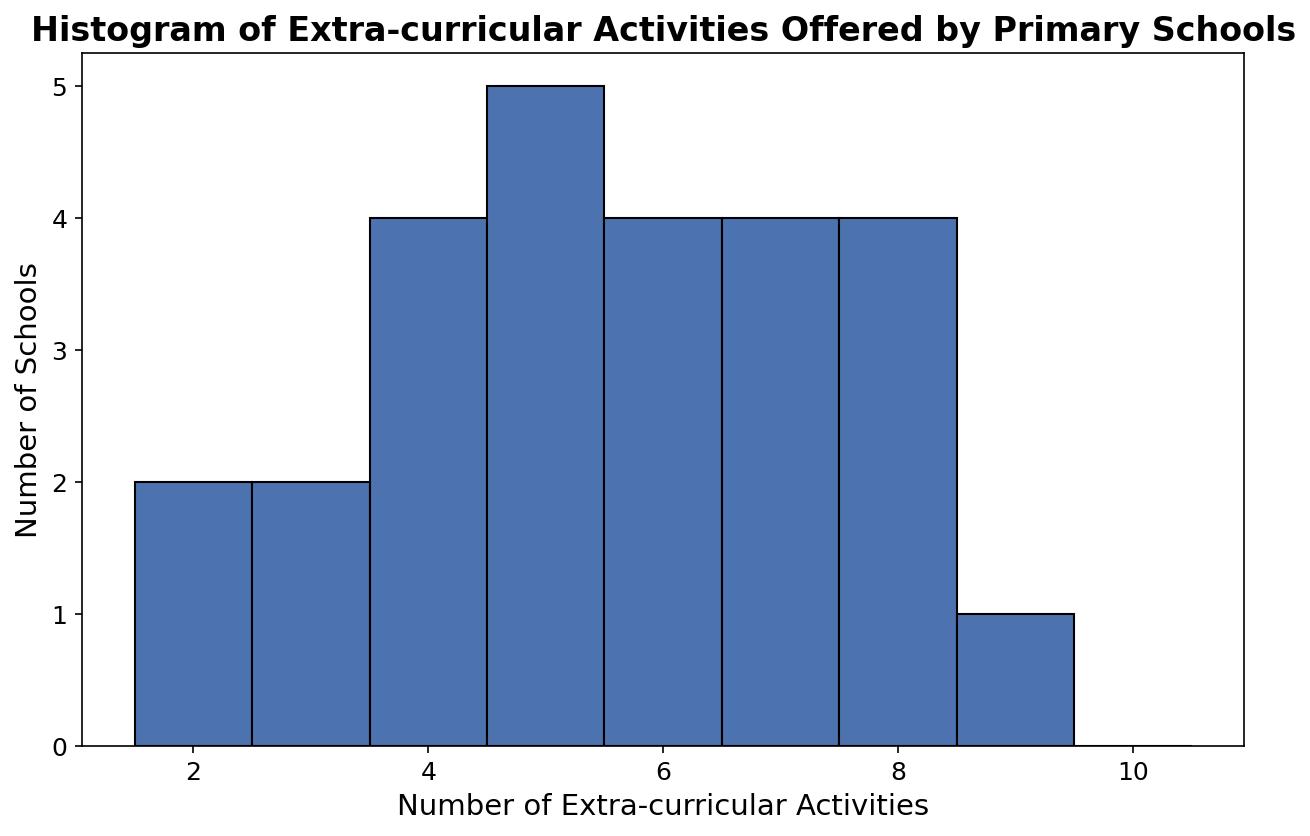How many schools offer exactly 5 extra-curricular activities? To determine this, locate the bar that corresponds to 5 extra-curricular activities. Count the height of this bar, which represents the number of schools.
Answer: 4 Which number of extra-curricular activities is most common among the schools? Identify the tallest bar in the histogram. The label on the x-axis at the base of this bar represents the most common number of extra-curricular activities.
Answer: 7 How many more schools offer 7 activities compared to those that offer 3 activities? First, find the height of the bars corresponding to 7 and 3 activities. Subtract the number of schools that offer 3 activities from those that offer 7.
Answer: 2 What is the total number of schools that offer more than 6 extra-curricular activities? Locate the bars corresponding to 7, 8, and 9 activities. Sum their heights to find the total number of schools offering more than 6 activities.
Answer: 10 Are there more schools offering fewer than 5 activities or those offering 5 or more activities? First, sum the heights of the bars for 2, 3, and 4 activities for the count of schools offering fewer than 5 activities. Then, sum the heights of the bars for 5, 6, 7, 8, and 9 activities for the count of schools offering 5 or more activities. Compare the two sums.
Answer: More schools offer 5 or more activities What's the difference in the number of schools offering the least and the most common number of extra-curricular activities? Identify the tallest bar (most common) and the shortest bar (least common). Note the heights of these bars. Subtract the height of the least common bar from the tallest.
Answer: 5 How many schools in total were surveyed in the histogram? Sum the heights of all the bars in the histogram to get the total number of schools.
Answer: 26 If a new activity is added to each school's extra-curricular offerings, how many schools would then offer exactly 6 activities? Locate the bars for 5 and 6 activities. The number of schools currently offering 5 activities will be added to those already offering 6.
Answer: 8 What percentage of schools offer at least 8 extra-curricular activities? First, find the total number of schools that offer 8 or more activities. Then, divide this sum by the total number of schools and multiply by 100 to convert to a percentage.
Answer: 23.08% If a school offering 2 activities starts offering 4 more, how many schools will then offer 6 activities? Find the number of schools currently offering 2 activities. Add this to the current count of schools offering 6 activities.
Answer: 7 